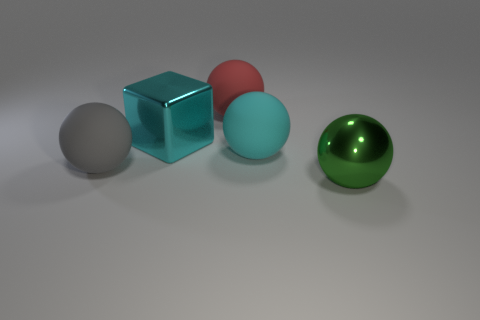How many large shiny objects are both on the right side of the big red object and behind the large cyan ball? There are no large shiny objects that satisfy both conditions of being on the right side of the big red object and behind the large cyan ball. The objects on the right of the red sphere are the cyan cube and the green sphere, but neither is behind the cyan ball when viewing the scene from the provided perspective. 